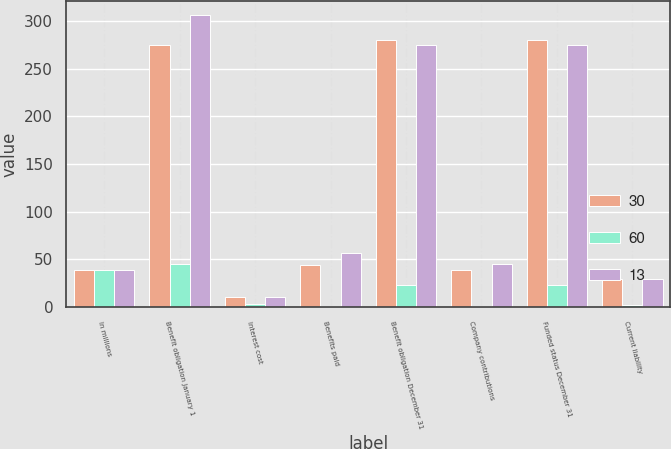Convert chart to OTSL. <chart><loc_0><loc_0><loc_500><loc_500><stacked_bar_chart><ecel><fcel>In millions<fcel>Benefit obligation January 1<fcel>Interest cost<fcel>Benefits paid<fcel>Benefit obligation December 31<fcel>Company contributions<fcel>Funded status December 31<fcel>Current liability<nl><fcel>30<fcel>39<fcel>275<fcel>11<fcel>44<fcel>280<fcel>39<fcel>280<fcel>29<nl><fcel>60<fcel>39<fcel>45<fcel>3<fcel>1<fcel>23<fcel>1<fcel>23<fcel>2<nl><fcel>13<fcel>39<fcel>306<fcel>11<fcel>57<fcel>275<fcel>45<fcel>275<fcel>29<nl></chart> 